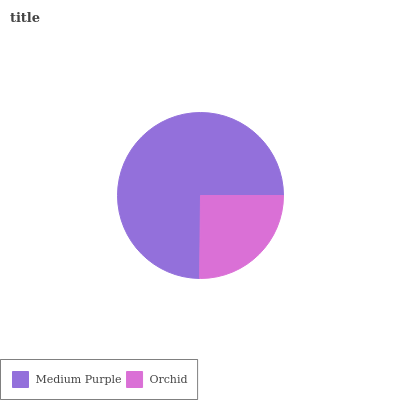Is Orchid the minimum?
Answer yes or no. Yes. Is Medium Purple the maximum?
Answer yes or no. Yes. Is Orchid the maximum?
Answer yes or no. No. Is Medium Purple greater than Orchid?
Answer yes or no. Yes. Is Orchid less than Medium Purple?
Answer yes or no. Yes. Is Orchid greater than Medium Purple?
Answer yes or no. No. Is Medium Purple less than Orchid?
Answer yes or no. No. Is Medium Purple the high median?
Answer yes or no. Yes. Is Orchid the low median?
Answer yes or no. Yes. Is Orchid the high median?
Answer yes or no. No. Is Medium Purple the low median?
Answer yes or no. No. 